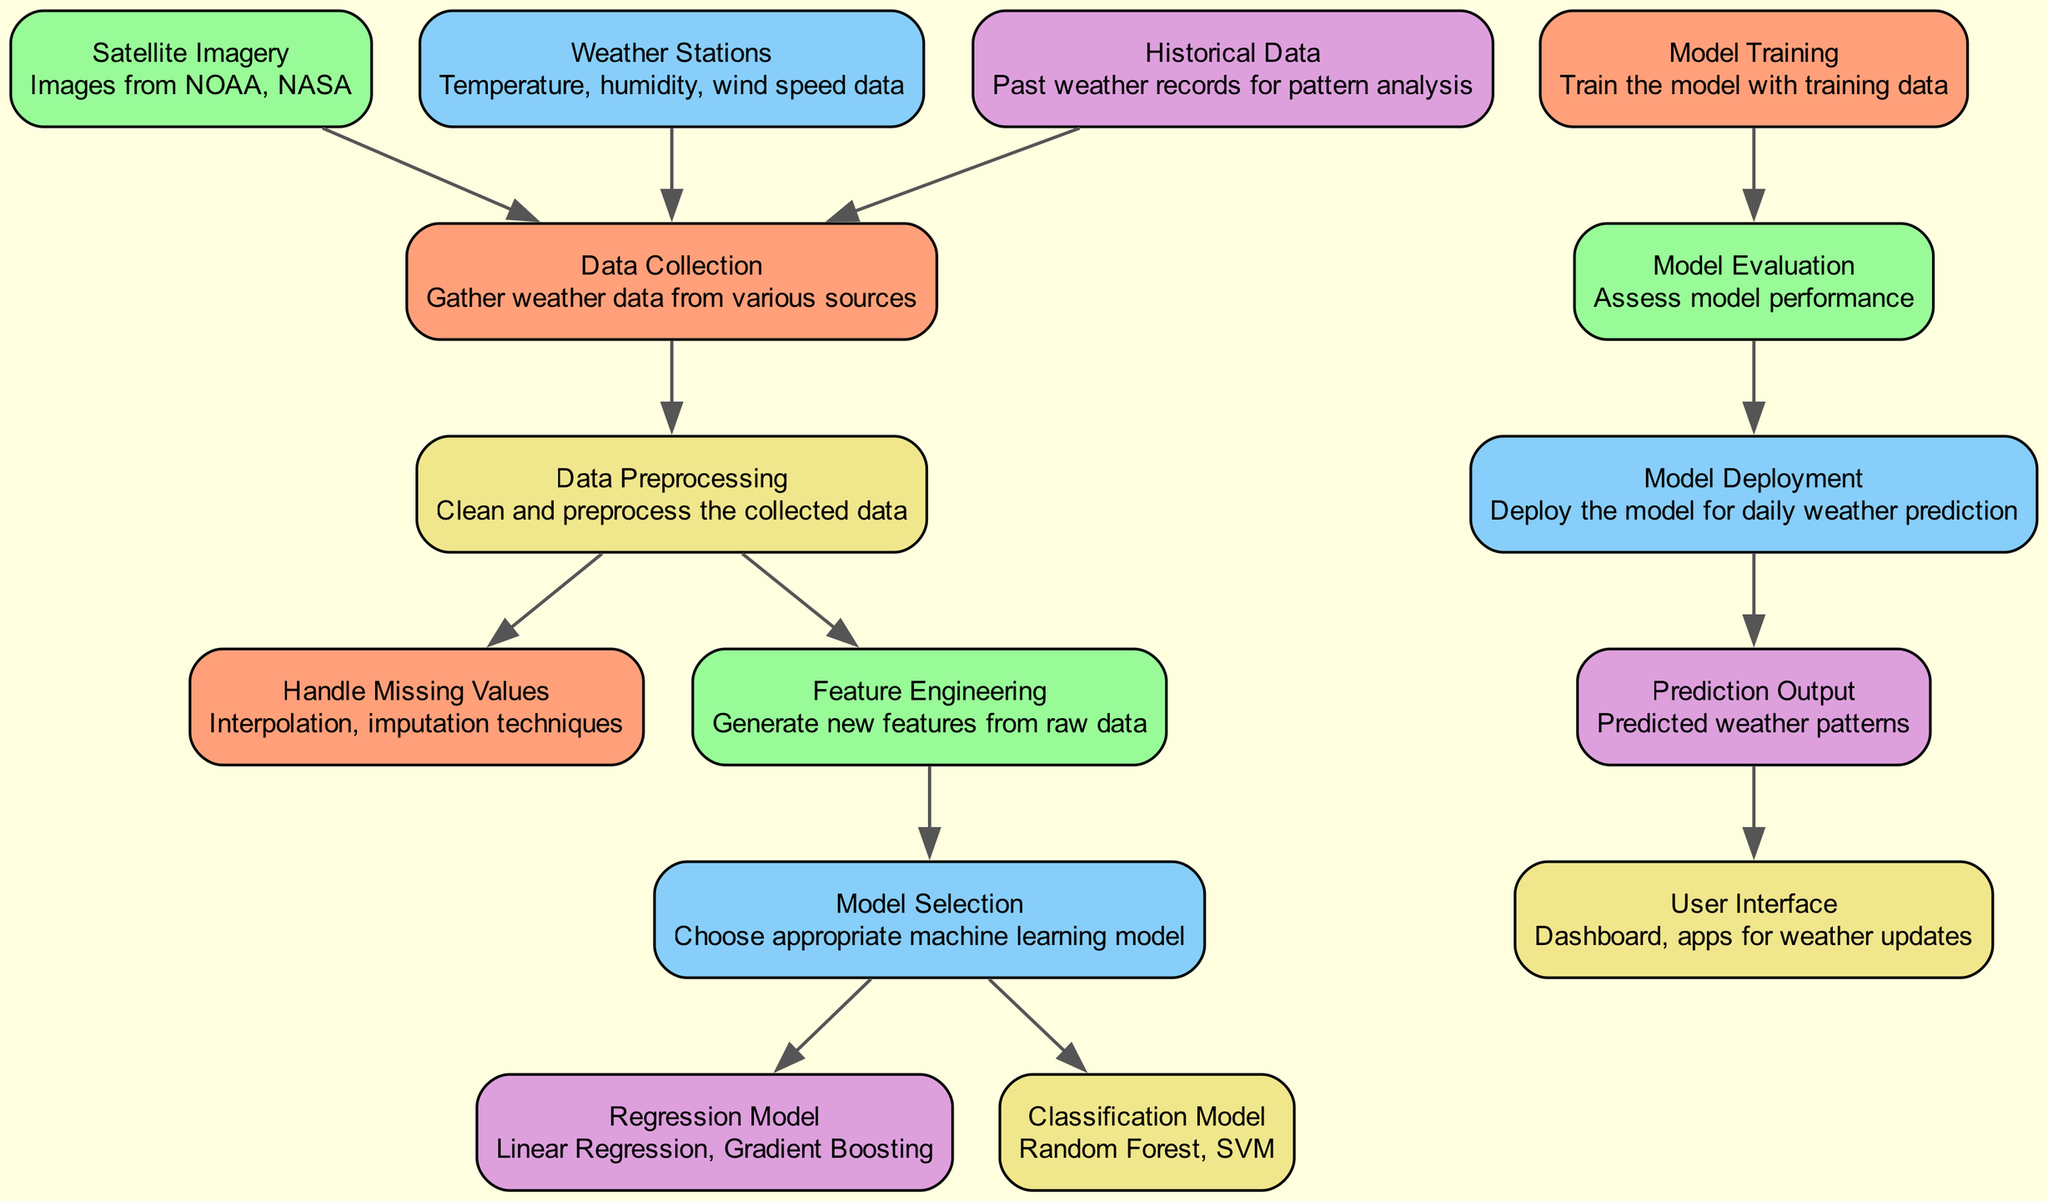What is the first node in the diagram? The first node is 'Data Collection'. It is the initial step in the process, indicating the gathering of weather data before any processing occurs.
Answer: Data Collection How many types of machine learning models are selected in this diagram? There are two types of models mentioned: regression model and classification model. Thus, the diagram indicates the selection of two types of machine learning models to predict weather patterns.
Answer: Two What node follows 'Data Preprocessing'? The node that follows 'Data Preprocessing' is 'Handle Missing Values', which implies that once data is preprocessed, the next step is to address any missing information in it.
Answer: Handle Missing Values What is the last node in the diagram? The last node is 'User Interface', which represents the final stage where the predicted weather patterns are presented to the users via a dashboard or application.
Answer: User Interface Which node describes the process of generating new features from raw data? The node that describes this process is 'Feature Engineering'. This is a crucial step where useful features are created to enhance model performance.
Answer: Feature Engineering Which node is connected to 'Model Training'? The node connected to 'Model Training' is 'Model Evaluation'. This indicates that after training the model, it is essential to evaluate its performance before deployment.
Answer: Model Evaluation How many edges are there in the diagram? There are twelve edges, as each edge represents a directional flow from one process to another within the weather prediction framework.
Answer: Twelve What is the purpose of the 'Model Deployment' node? The purpose of 'Model Deployment' is to implement the trained machine learning model so it can be used for daily weather predictions, making it actionable for end-users.
Answer: Deploy the model for daily weather prediction What type of data is collected from weather stations? From weather stations, data on temperature, humidity, and wind speed is gathered, providing essential metrics for weather analysis and prediction.
Answer: Temperature, humidity, wind speed data 